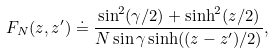<formula> <loc_0><loc_0><loc_500><loc_500>F _ { N } ( z , z ^ { \prime } ) \doteq \frac { \sin ^ { 2 } ( \gamma / 2 ) + \sinh ^ { 2 } ( z / 2 ) } { N \sin \gamma \sinh ( ( z - z ^ { \prime } ) / 2 ) } ,</formula> 